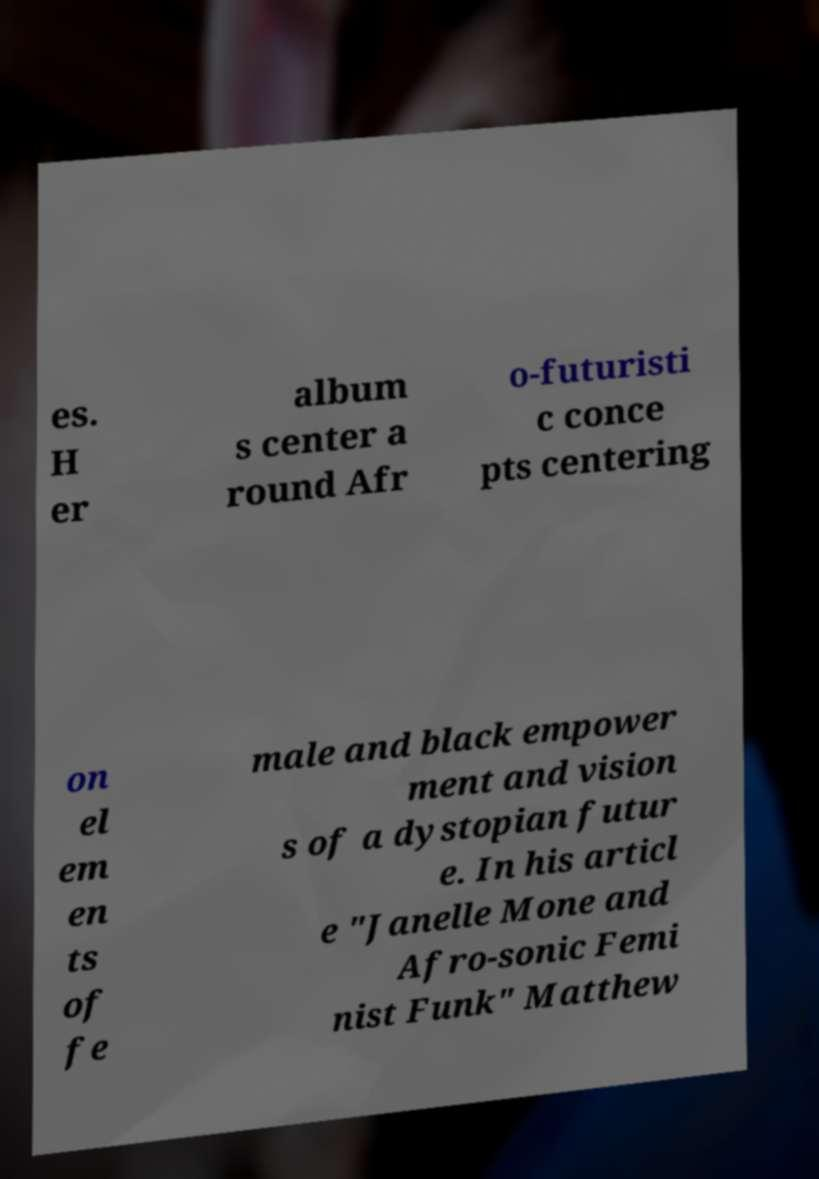Can you read and provide the text displayed in the image?This photo seems to have some interesting text. Can you extract and type it out for me? es. H er album s center a round Afr o-futuristi c conce pts centering on el em en ts of fe male and black empower ment and vision s of a dystopian futur e. In his articl e "Janelle Mone and Afro-sonic Femi nist Funk" Matthew 